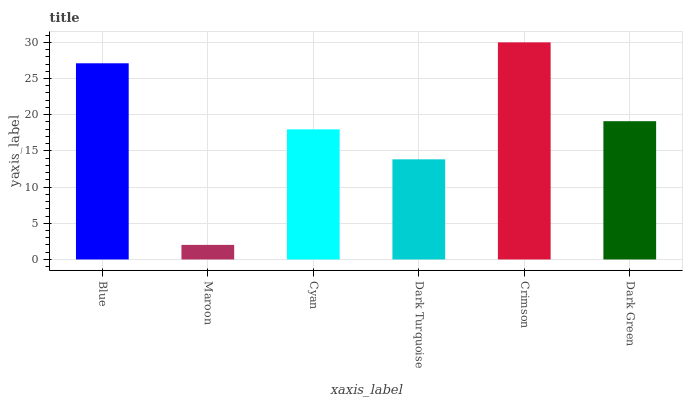Is Maroon the minimum?
Answer yes or no. Yes. Is Crimson the maximum?
Answer yes or no. Yes. Is Cyan the minimum?
Answer yes or no. No. Is Cyan the maximum?
Answer yes or no. No. Is Cyan greater than Maroon?
Answer yes or no. Yes. Is Maroon less than Cyan?
Answer yes or no. Yes. Is Maroon greater than Cyan?
Answer yes or no. No. Is Cyan less than Maroon?
Answer yes or no. No. Is Dark Green the high median?
Answer yes or no. Yes. Is Cyan the low median?
Answer yes or no. Yes. Is Maroon the high median?
Answer yes or no. No. Is Dark Green the low median?
Answer yes or no. No. 